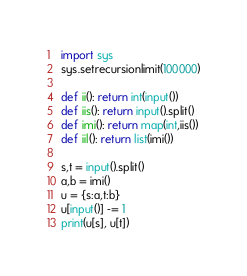Convert code to text. <code><loc_0><loc_0><loc_500><loc_500><_Python_>import sys
sys.setrecursionlimit(100000)

def ii(): return int(input())
def iis(): return input().split()
def imi(): return map(int,iis())
def iil(): return list(imi())

s,t = input().split()
a,b = imi()
u = {s:a,t:b}
u[input()] -= 1
print(u[s], u[t])</code> 